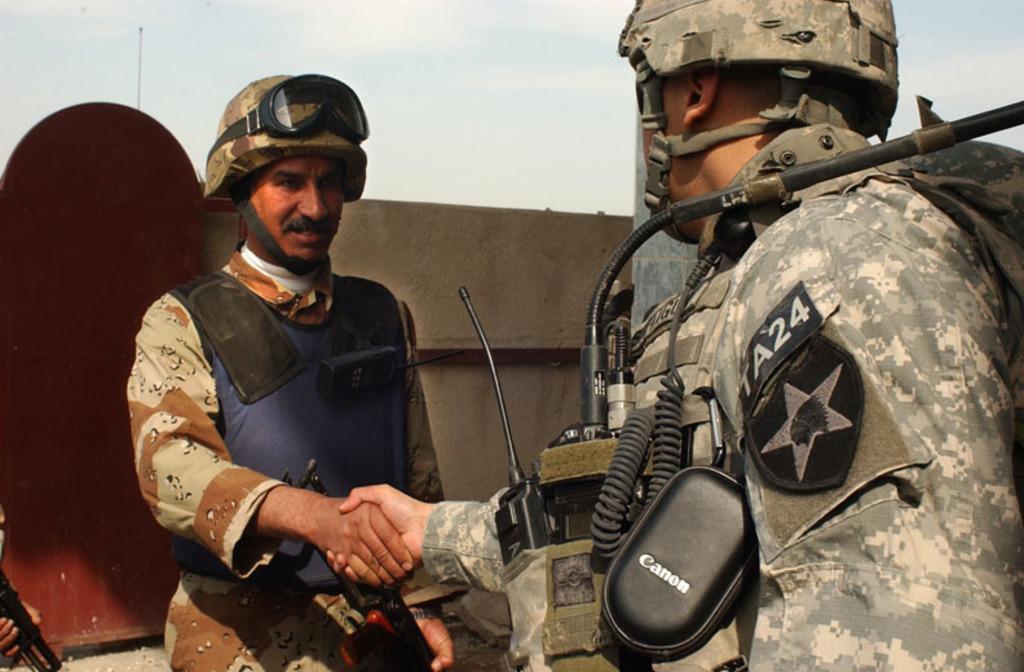Describe this image in one or two sentences. In this image, we can see people wearing uniforms and helmets and we can see a machine. In the background, there is a gate and we can see a person holding a gun and there is a pole. At the top, there is sky. 